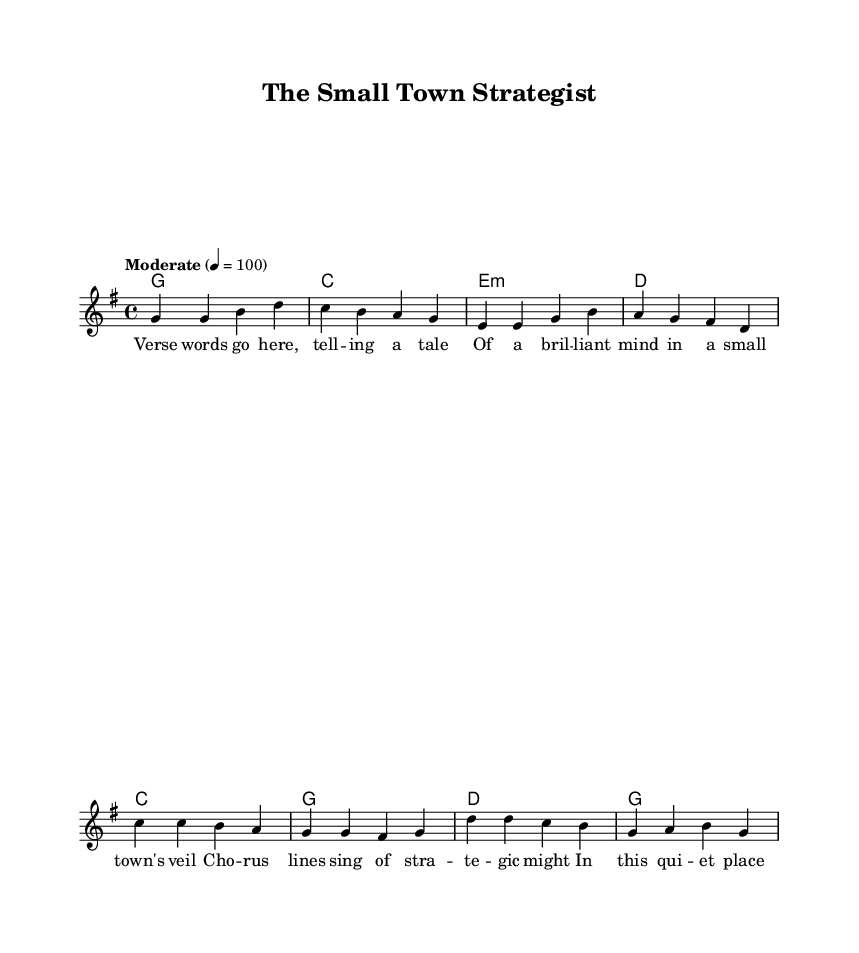What is the key signature of this music? The key signature is G major, which has one sharp (F#).
Answer: G major What is the time signature of the piece? The time signature is written at the beginning of the score, and it indicates that there are four beats per measure.
Answer: 4/4 What is the tempo marking for the piece? The tempo marking "Moderate" indicates a speed of quarter note equals 100 beats per minute, which is a moderate tempo.
Answer: Moderate How many measures are there in the verse? By counting the measure lines within the verse section, we see there are a total of four measures.
Answer: 4 What is the first note of the chorus? The first note of the chorus is C, as indicated by the melody notes at the beginning of that section.
Answer: C In which section does the word "strategic" appear? The word "strategic" appears in the chorus lyrics, which detail the themes of the song relating to the strategist's capabilities.
Answer: Chorus What is the nature of the story being told in the lyrics? The story details the life of a brilliant strategist living in a small town, illustrating his strategic prowess and the context of his environment.
Answer: Storytelling 